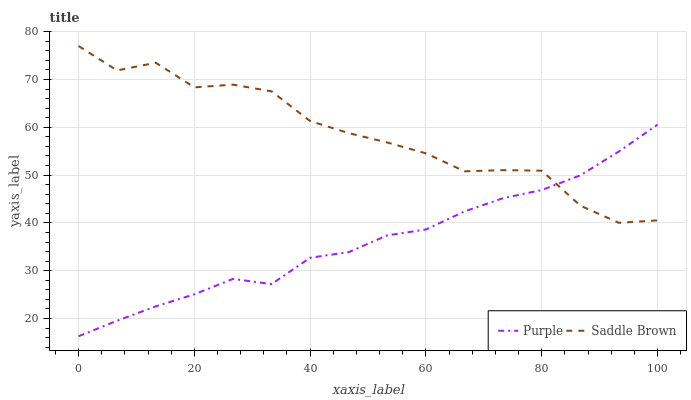Does Purple have the minimum area under the curve?
Answer yes or no. Yes. Does Saddle Brown have the maximum area under the curve?
Answer yes or no. Yes. Does Saddle Brown have the minimum area under the curve?
Answer yes or no. No. Is Purple the smoothest?
Answer yes or no. Yes. Is Saddle Brown the roughest?
Answer yes or no. Yes. Is Saddle Brown the smoothest?
Answer yes or no. No. Does Purple have the lowest value?
Answer yes or no. Yes. Does Saddle Brown have the lowest value?
Answer yes or no. No. Does Saddle Brown have the highest value?
Answer yes or no. Yes. Does Saddle Brown intersect Purple?
Answer yes or no. Yes. Is Saddle Brown less than Purple?
Answer yes or no. No. Is Saddle Brown greater than Purple?
Answer yes or no. No. 